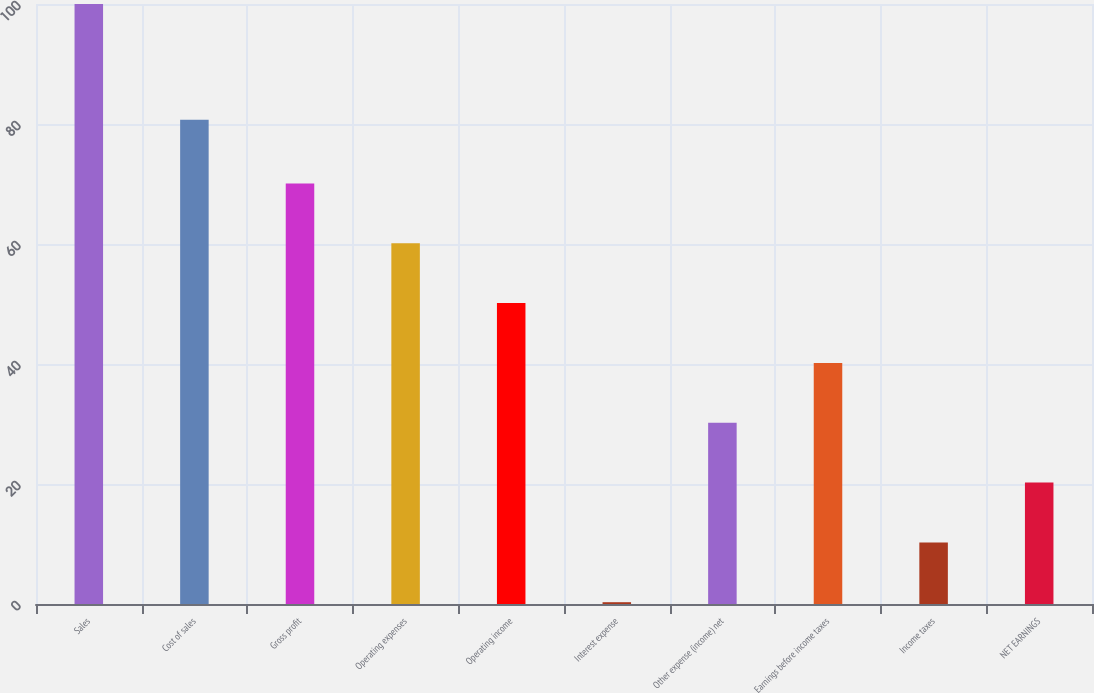Convert chart. <chart><loc_0><loc_0><loc_500><loc_500><bar_chart><fcel>Sales<fcel>Cost of sales<fcel>Gross profit<fcel>Operating expenses<fcel>Operating income<fcel>Interest expense<fcel>Other expense (income) net<fcel>Earnings before income taxes<fcel>Income taxes<fcel>NET EARNINGS<nl><fcel>100<fcel>80.7<fcel>70.09<fcel>60.12<fcel>50.15<fcel>0.3<fcel>30.21<fcel>40.18<fcel>10.27<fcel>20.24<nl></chart> 